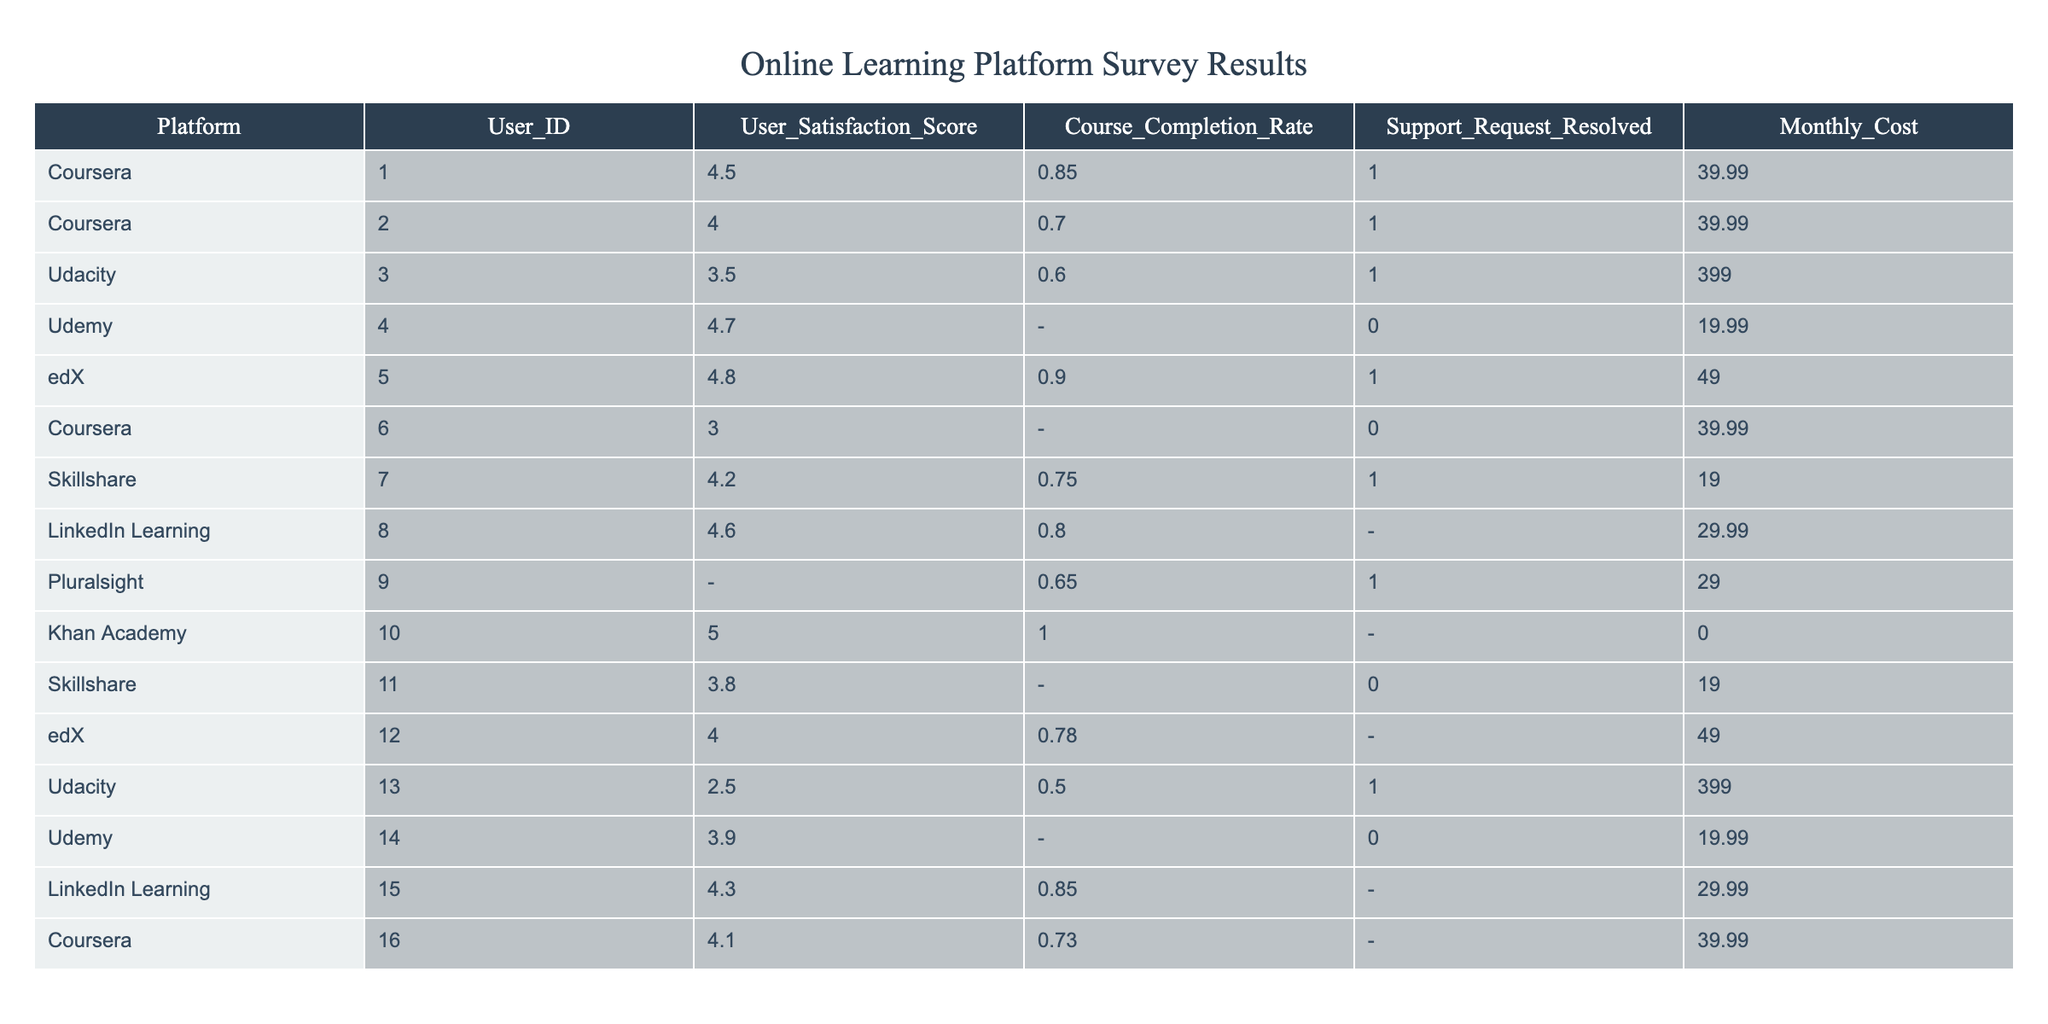What is the user satisfaction score for Udacity? The user satisfaction score for Udacity can be found by looking at the corresponding row for Udacity in the table. It shows a score of 3.5 for User_ID 3 and 2.5 for User_ID 13.
Answer: 3.5 and 2.5 Which online learning platform has the highest user satisfaction score? To determine the platform with the highest satisfaction score, I need to compare all the listed scores. The highest score is 5.0 for Khan Academy.
Answer: Khan Academy What is the monthly cost of Coursera? The monthly cost for Coursera can be identified by looking at the rows corresponding to Coursera. All instances show a cost of 39.99.
Answer: 39.99 Is there any platform with a course completion rate of 1.00? I check all completion rates in the table, and find that Khan Academy has a course completion rate of 1.00.
Answer: Yes What is the average user satisfaction score across all platforms? I sum the user satisfaction scores from all available data (4.5 + 4.0 + 3.5 + 4.7 + 4.8 + 3.0 + 4.2 + 4.6 + 5.0 + 3.8 + 4.0 + 2.5 + 3.9 + 4.1). There are 14 entries, and the average is calculated by dividing the total by 14. The total is 56.8, so the average is 56.8 / 14 = 4.057.
Answer: 4.06 What is the course completion rate for Udemy? I look at the table for Udemy and notice that the course completion rate is missing (NaN) for both entries related to Udemy.
Answer: Not available Which platform had the highest percentage of support requests resolved? I review the support request resolution data for each platform and find that out of the entries listed, Udacity, with 1 request resolved out of 1, indicates the highest percentage.
Answer: Udacity How many platforms have a monthly cost above $39.99? I check the monthly costs for all platforms and see that Udacity (399.00) is the only one significantly above 39.99. I also find Coursera but it is exactly 39.99.
Answer: 1 